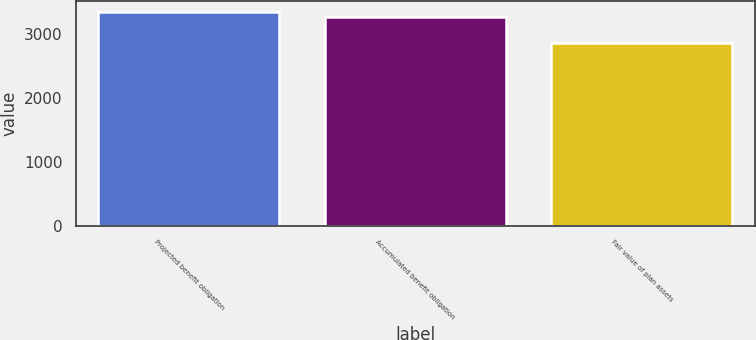<chart> <loc_0><loc_0><loc_500><loc_500><bar_chart><fcel>Projected benefit obligation<fcel>Accumulated benefit obligation<fcel>Fair value of plan assets<nl><fcel>3338.8<fcel>3260.7<fcel>2863.3<nl></chart> 